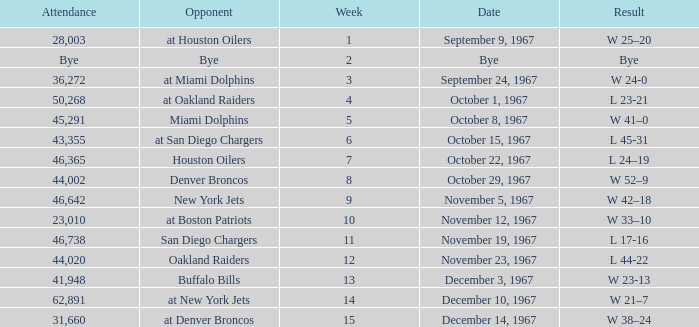What was the date of the game after week 5 against the Houston Oilers? October 22, 1967. Could you parse the entire table as a dict? {'header': ['Attendance', 'Opponent', 'Week', 'Date', 'Result'], 'rows': [['28,003', 'at Houston Oilers', '1', 'September 9, 1967', 'W 25–20'], ['Bye', 'Bye', '2', 'Bye', 'Bye'], ['36,272', 'at Miami Dolphins', '3', 'September 24, 1967', 'W 24-0'], ['50,268', 'at Oakland Raiders', '4', 'October 1, 1967', 'L 23-21'], ['45,291', 'Miami Dolphins', '5', 'October 8, 1967', 'W 41–0'], ['43,355', 'at San Diego Chargers', '6', 'October 15, 1967', 'L 45-31'], ['46,365', 'Houston Oilers', '7', 'October 22, 1967', 'L 24–19'], ['44,002', 'Denver Broncos', '8', 'October 29, 1967', 'W 52–9'], ['46,642', 'New York Jets', '9', 'November 5, 1967', 'W 42–18'], ['23,010', 'at Boston Patriots', '10', 'November 12, 1967', 'W 33–10'], ['46,738', 'San Diego Chargers', '11', 'November 19, 1967', 'L 17-16'], ['44,020', 'Oakland Raiders', '12', 'November 23, 1967', 'L 44-22'], ['41,948', 'Buffalo Bills', '13', 'December 3, 1967', 'W 23-13'], ['62,891', 'at New York Jets', '14', 'December 10, 1967', 'W 21–7'], ['31,660', 'at Denver Broncos', '15', 'December 14, 1967', 'W 38–24']]} 